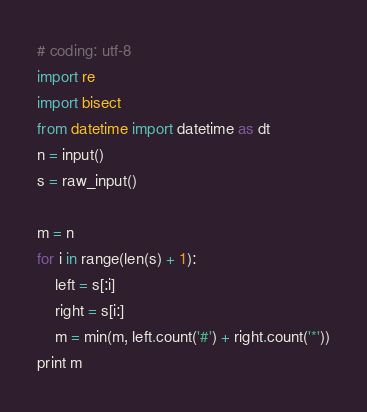<code> <loc_0><loc_0><loc_500><loc_500><_Python_># coding: utf-8
import re
import bisect
from datetime import datetime as dt
n = input()
s = raw_input()

m = n
for i in range(len(s) + 1):
    left = s[:i]
    right = s[i:]
    m = min(m, left.count('#') + right.count('*'))
print m
</code> 